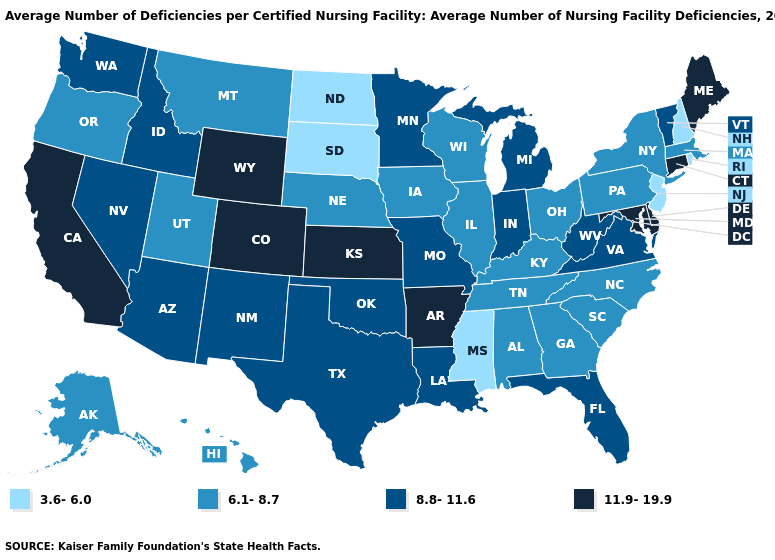What is the lowest value in states that border Texas?
Concise answer only. 8.8-11.6. How many symbols are there in the legend?
Give a very brief answer. 4. Does Arizona have the lowest value in the West?
Quick response, please. No. Does the first symbol in the legend represent the smallest category?
Concise answer only. Yes. What is the lowest value in the MidWest?
Answer briefly. 3.6-6.0. Does Oregon have the lowest value in the West?
Concise answer only. Yes. How many symbols are there in the legend?
Quick response, please. 4. Does Colorado have the highest value in the USA?
Give a very brief answer. Yes. Does Colorado have the same value as California?
Answer briefly. Yes. What is the lowest value in the West?
Keep it brief. 6.1-8.7. Does the map have missing data?
Concise answer only. No. Name the states that have a value in the range 6.1-8.7?
Keep it brief. Alabama, Alaska, Georgia, Hawaii, Illinois, Iowa, Kentucky, Massachusetts, Montana, Nebraska, New York, North Carolina, Ohio, Oregon, Pennsylvania, South Carolina, Tennessee, Utah, Wisconsin. Name the states that have a value in the range 11.9-19.9?
Quick response, please. Arkansas, California, Colorado, Connecticut, Delaware, Kansas, Maine, Maryland, Wyoming. What is the value of New York?
Write a very short answer. 6.1-8.7. Which states have the lowest value in the USA?
Short answer required. Mississippi, New Hampshire, New Jersey, North Dakota, Rhode Island, South Dakota. 